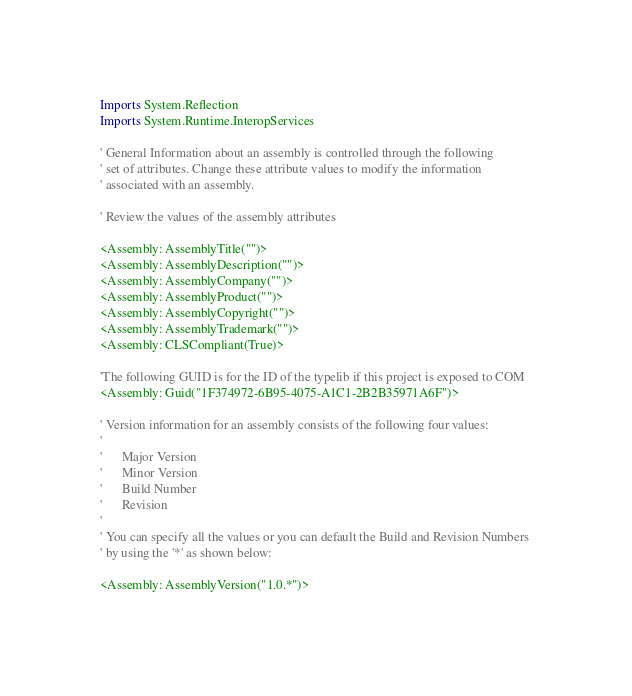Convert code to text. <code><loc_0><loc_0><loc_500><loc_500><_VisualBasic_>Imports System.Reflection
Imports System.Runtime.InteropServices

' General Information about an assembly is controlled through the following 
' set of attributes. Change these attribute values to modify the information
' associated with an assembly.

' Review the values of the assembly attributes

<Assembly: AssemblyTitle("")> 
<Assembly: AssemblyDescription("")> 
<Assembly: AssemblyCompany("")> 
<Assembly: AssemblyProduct("")> 
<Assembly: AssemblyCopyright("")> 
<Assembly: AssemblyTrademark("")> 
<Assembly: CLSCompliant(True)> 

'The following GUID is for the ID of the typelib if this project is exposed to COM
<Assembly: Guid("1F374972-6B95-4075-A1C1-2B2B35971A6F")> 

' Version information for an assembly consists of the following four values:
'
'      Major Version
'      Minor Version 
'      Build Number
'      Revision
'
' You can specify all the values or you can default the Build and Revision Numbers 
' by using the '*' as shown below:

<Assembly: AssemblyVersion("1.0.*")> 
</code> 